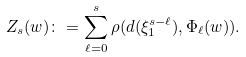Convert formula to latex. <formula><loc_0><loc_0><loc_500><loc_500>Z _ { s } ( w ) \colon = \sum _ { \ell = 0 } ^ { s } \rho ( d ( \xi _ { 1 } ^ { s - \ell } ) , \Phi _ { \ell } ( w ) ) .</formula> 